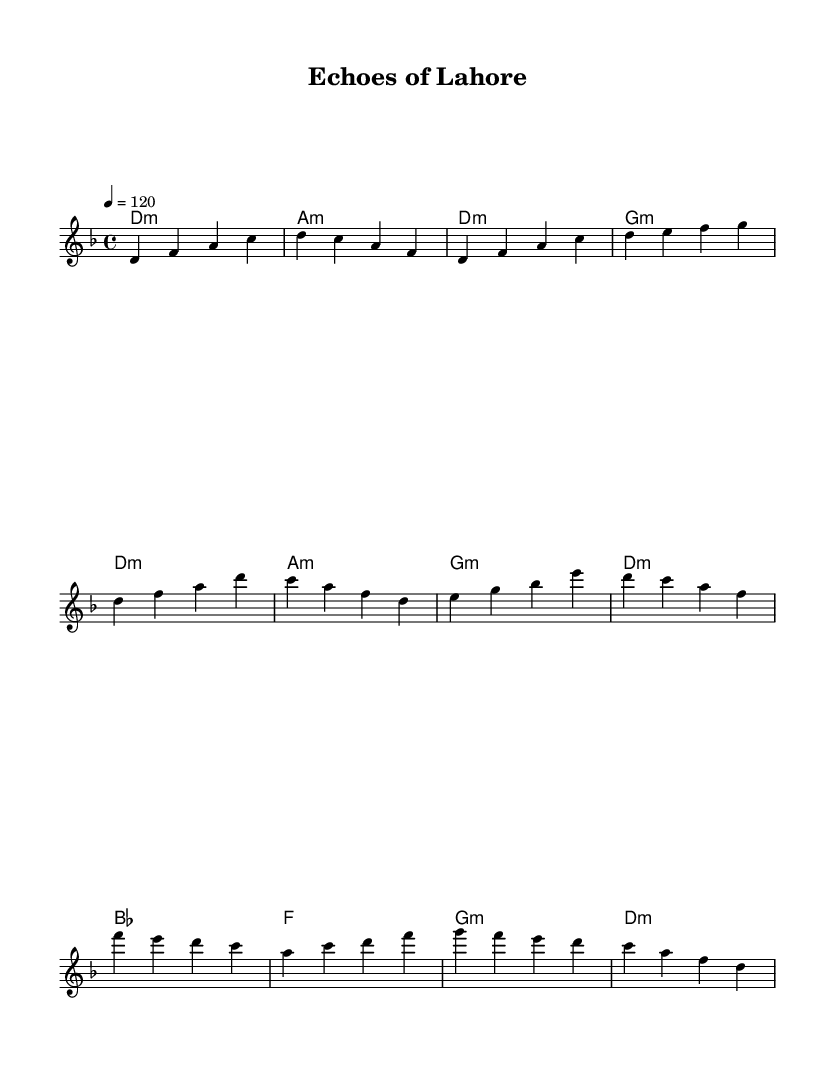What is the key signature of this music? The key signature indicated in the score is D minor, which has one flat.
Answer: D minor What is the time signature of this music? The time signature shown at the beginning of the score is 4/4, meaning there are four beats in each measure.
Answer: 4/4 What is the tempo marking for this piece? The tempo indication reads "4 = 120," which means the quarter note should be played at a speed of 120 beats per minute.
Answer: 120 How many measures are in the chorus section? The chorus section consists of four measures, as observed in the notation.
Answer: 4 What chord follows the first melody note in the introduction? The introduction starts with a D minor chord (D1:m), as noted in the chord section corresponding to the first melody note.
Answer: D minor In which musical form is the song structured, based on the sections observed? The song follows a typical verse-chorus form, consisting of an introduction, verse, and chorus sections.
Answer: Verse-Chorus What is the melodic range of the piece? The melody spans from D in the lower octave to A in the higher octave, suggesting a range of just over an octave.
Answer: Octave 